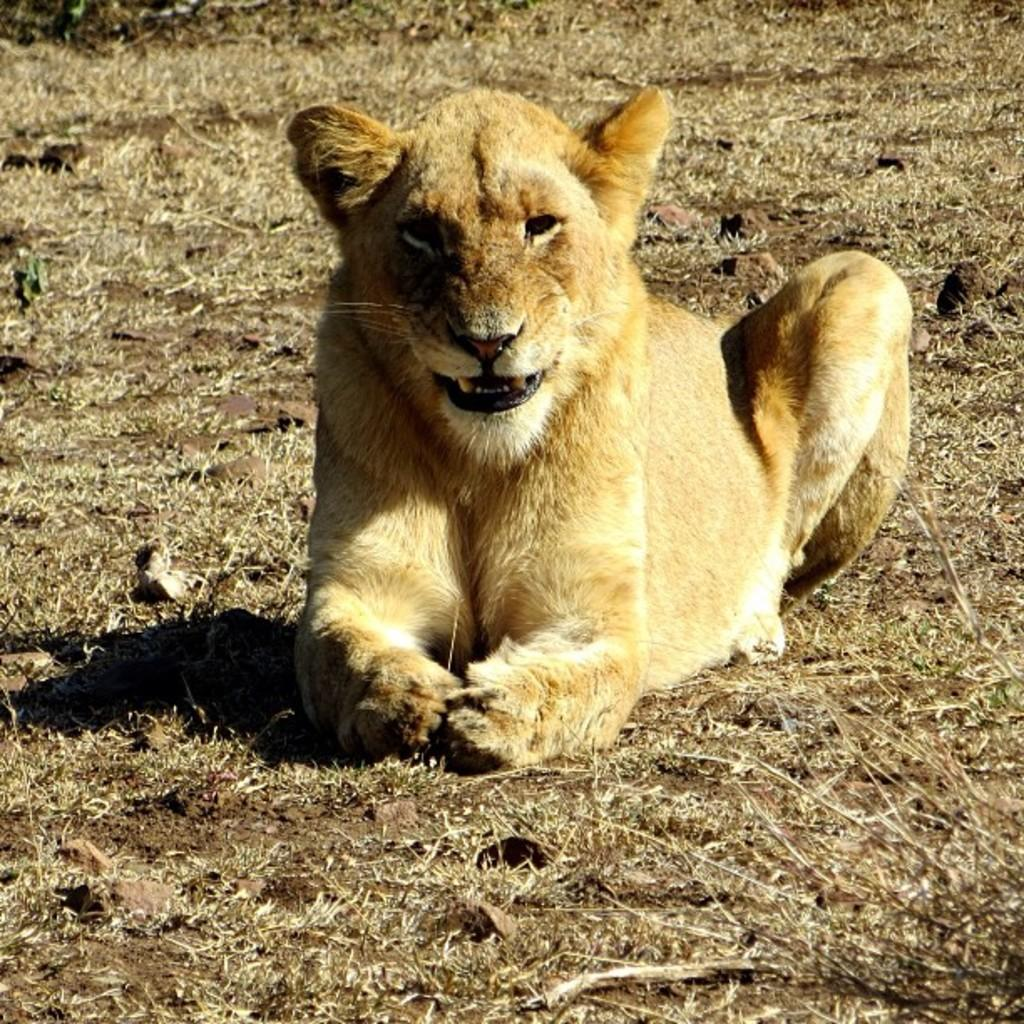What animal is in the image? There is a lion in the image. Where is the lion located? The lion is in the grass. What type of laborer can be seen working in the grass with the lion? There are no laborers present in the image; it only features a lion in the grass. What sense is the lion using to interact with the grass? The image does not provide information about the lion's senses or its interaction with the grass. 